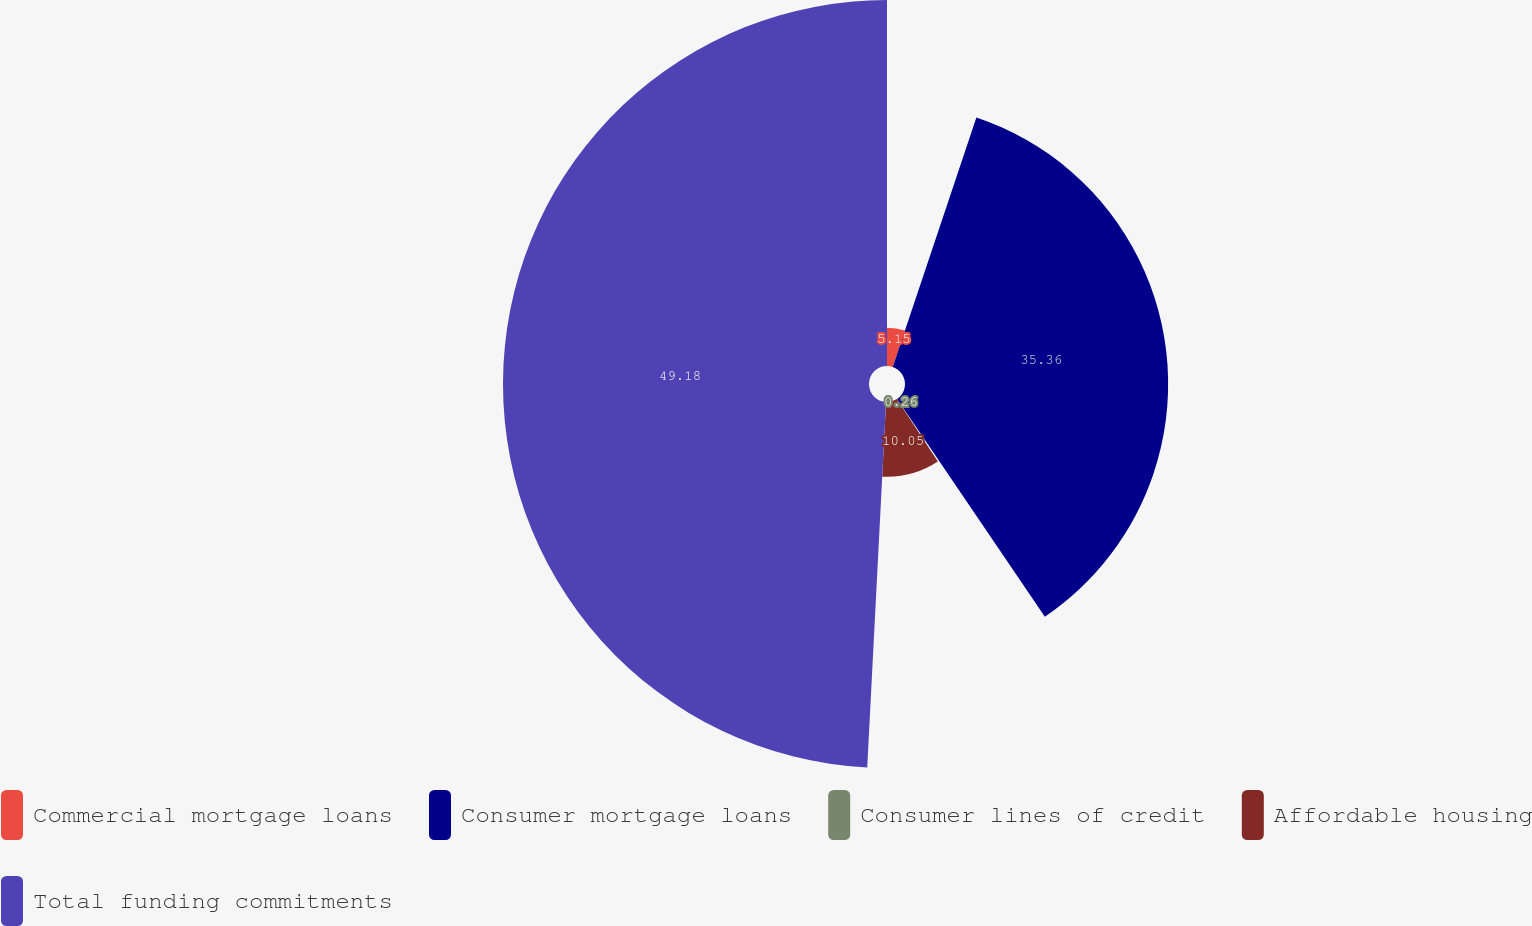Convert chart. <chart><loc_0><loc_0><loc_500><loc_500><pie_chart><fcel>Commercial mortgage loans<fcel>Consumer mortgage loans<fcel>Consumer lines of credit<fcel>Affordable housing<fcel>Total funding commitments<nl><fcel>5.15%<fcel>35.36%<fcel>0.26%<fcel>10.05%<fcel>49.18%<nl></chart> 